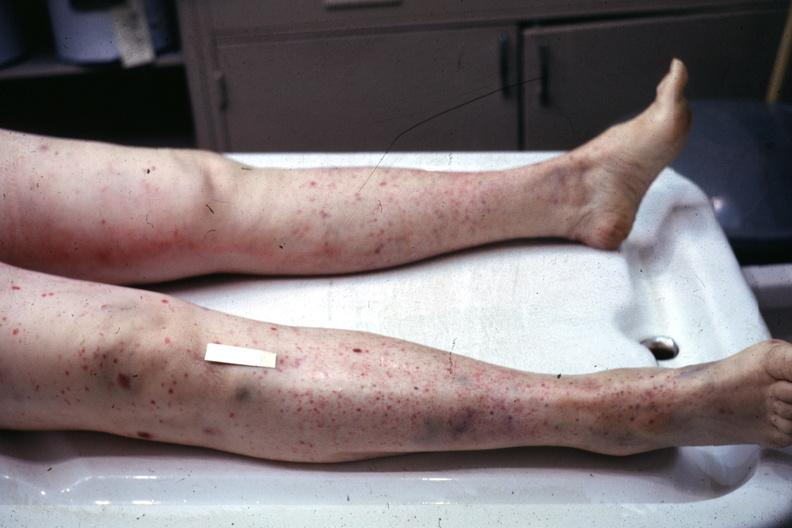re extremities present?
Answer the question using a single word or phrase. Yes 